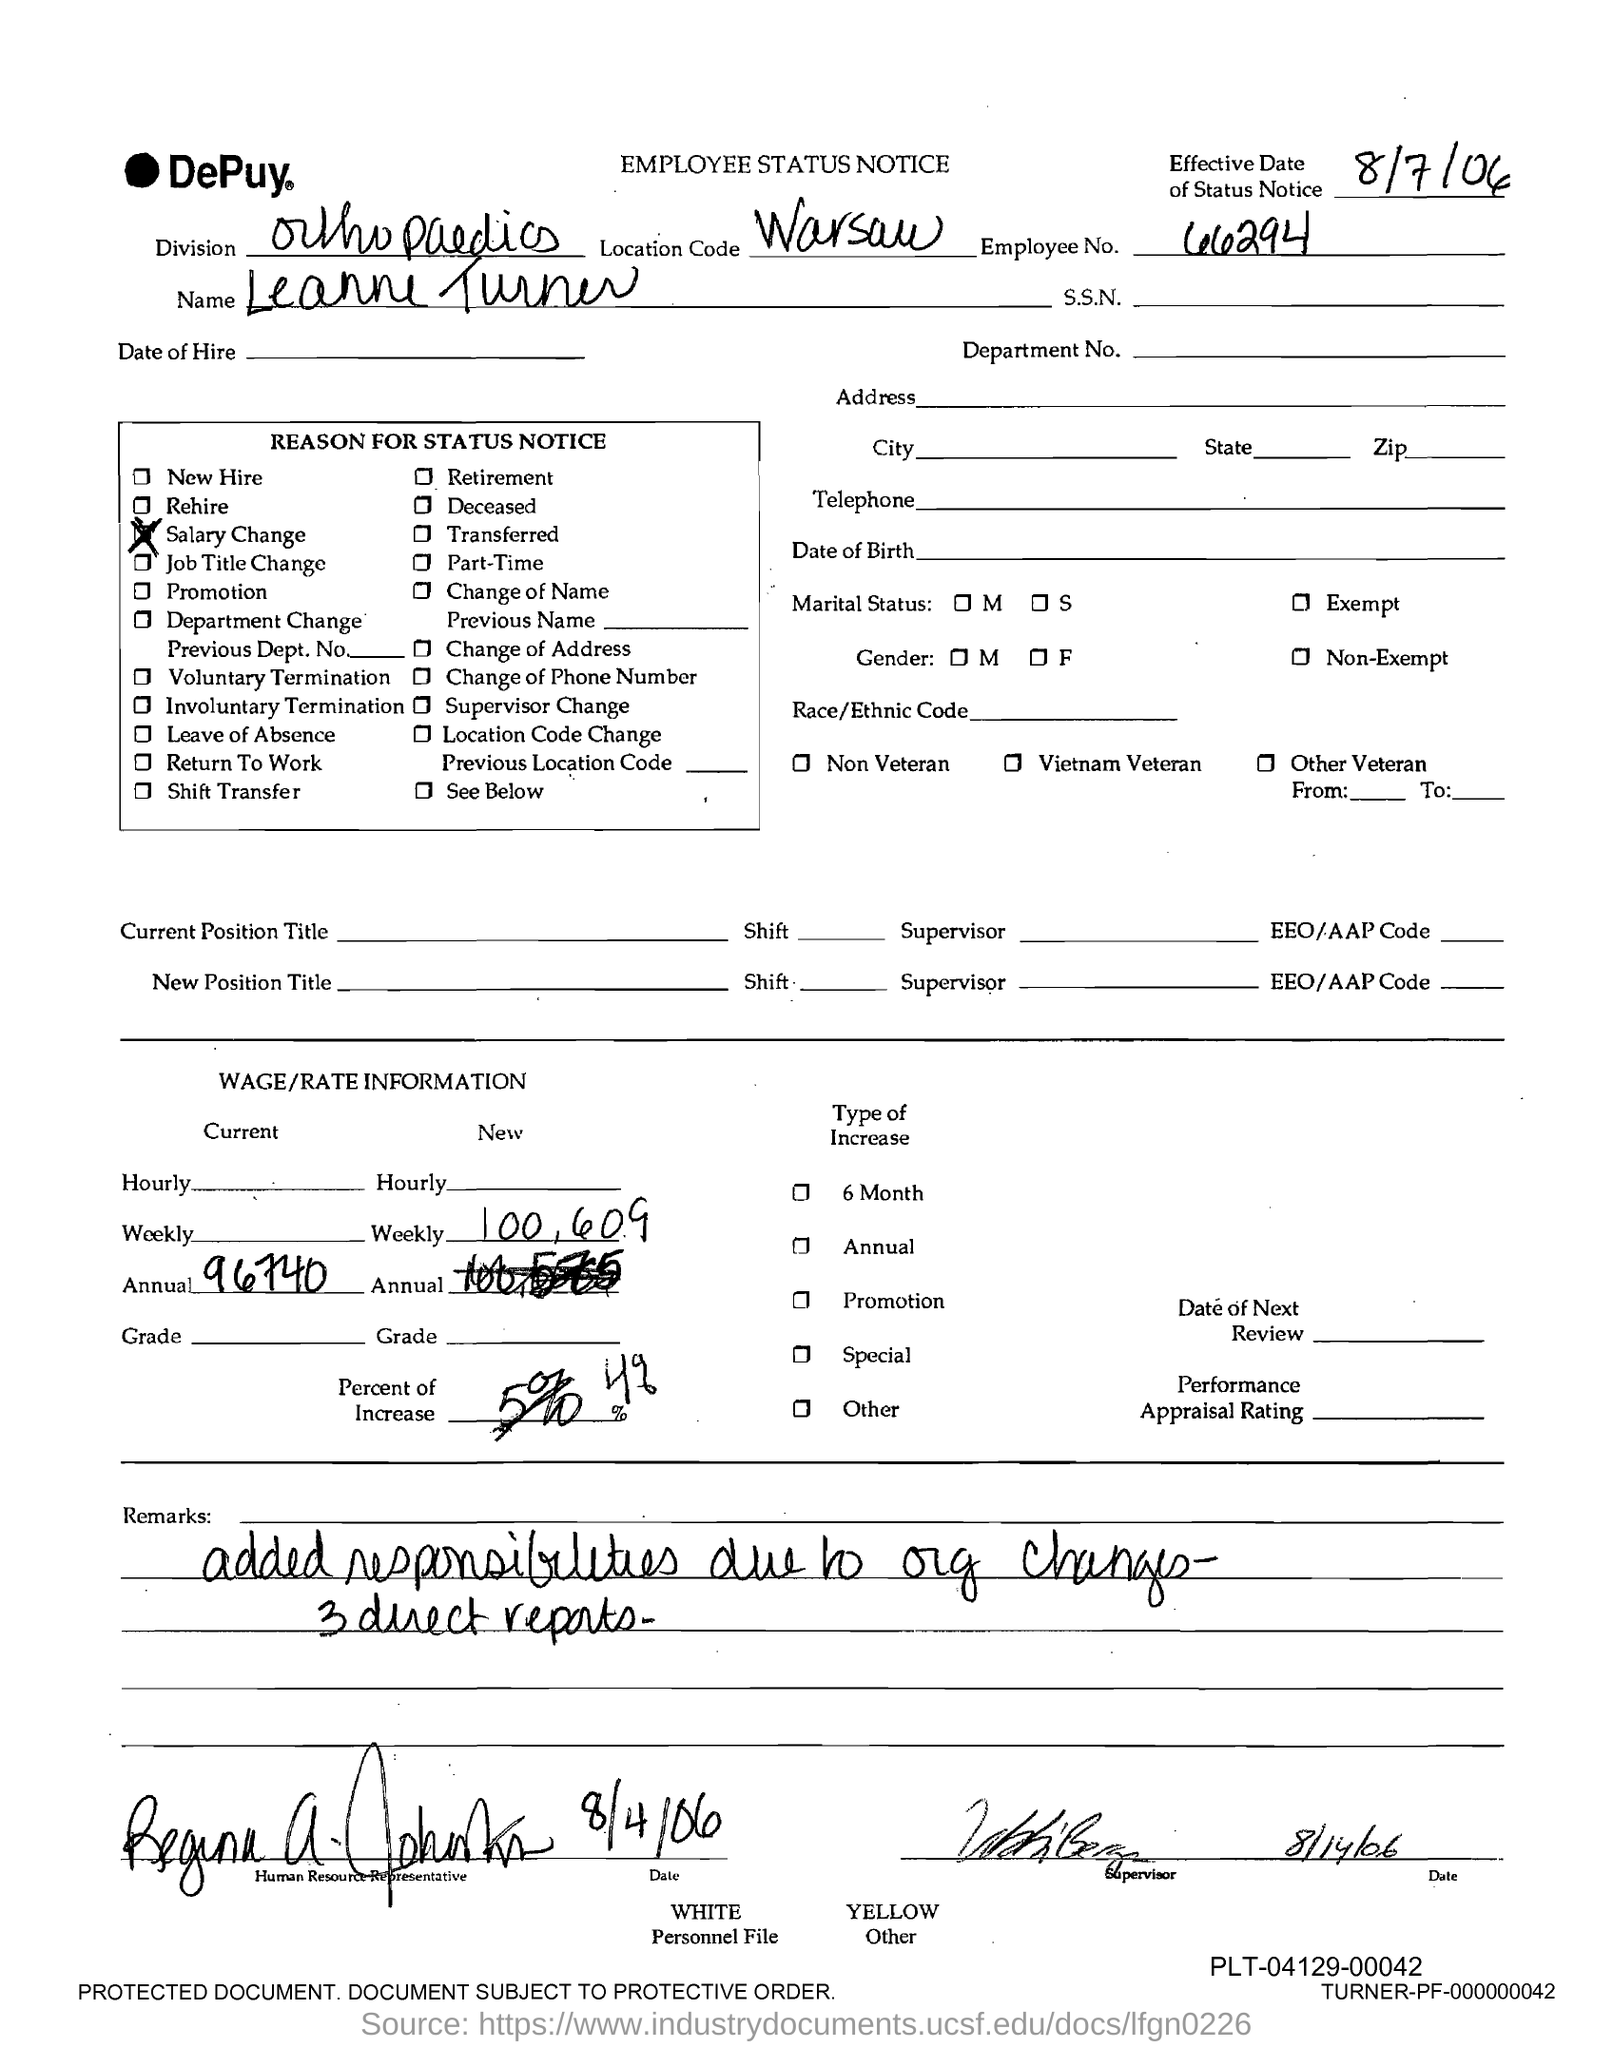What type of notice is this?
Give a very brief answer. EMPLOYEE STATUS NOTICE. What is the employee no. mentioned in the status notice?
Your answer should be compact. 66294. Who's employee status notice is this?
Keep it short and to the point. Leanne Turner. What is the location code given in the status notice?
Your response must be concise. Warsaw. In which division, Leanne Turner works?
Make the answer very short. Orthopaedics. What is the reason for status notice?
Your answer should be compact. Salary Change. 